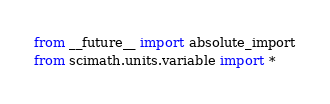Convert code to text. <code><loc_0><loc_0><loc_500><loc_500><_Python_>from __future__ import absolute_import
from scimath.units.variable import *
</code> 